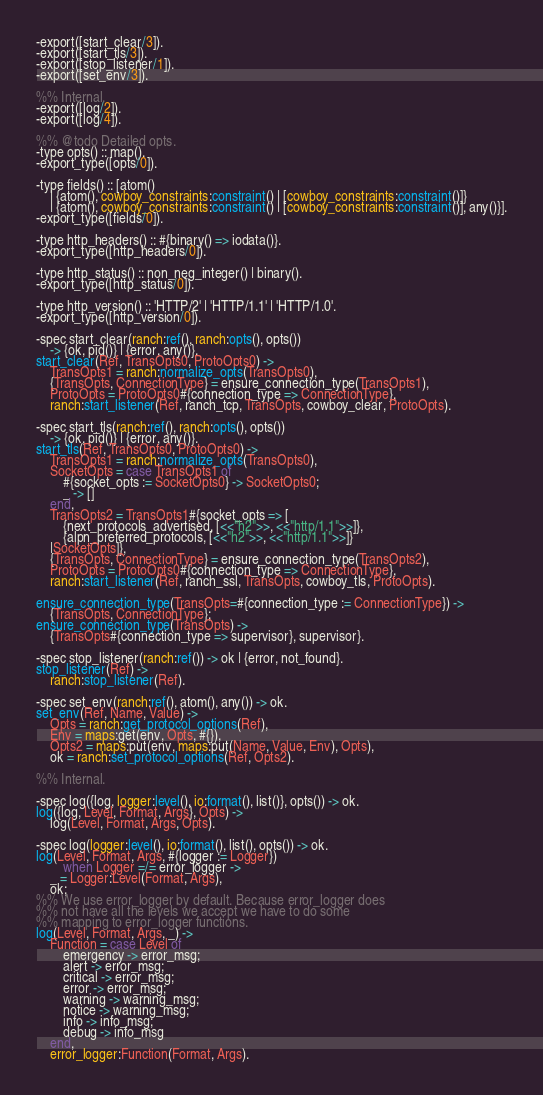<code> <loc_0><loc_0><loc_500><loc_500><_Erlang_>-export([start_clear/3]).
-export([start_tls/3]).
-export([stop_listener/1]).
-export([set_env/3]).

%% Internal.
-export([log/2]).
-export([log/4]).

%% @todo Detailed opts.
-type opts() :: map().
-export_type([opts/0]).

-type fields() :: [atom()
	| {atom(), cowboy_constraints:constraint() | [cowboy_constraints:constraint()]}
	| {atom(), cowboy_constraints:constraint() | [cowboy_constraints:constraint()], any()}].
-export_type([fields/0]).

-type http_headers() :: #{binary() => iodata()}.
-export_type([http_headers/0]).

-type http_status() :: non_neg_integer() | binary().
-export_type([http_status/0]).

-type http_version() :: 'HTTP/2' | 'HTTP/1.1' | 'HTTP/1.0'.
-export_type([http_version/0]).

-spec start_clear(ranch:ref(), ranch:opts(), opts())
	-> {ok, pid()} | {error, any()}.
start_clear(Ref, TransOpts0, ProtoOpts0) ->
	TransOpts1 = ranch:normalize_opts(TransOpts0),
	{TransOpts, ConnectionType} = ensure_connection_type(TransOpts1),
	ProtoOpts = ProtoOpts0#{connection_type => ConnectionType},
	ranch:start_listener(Ref, ranch_tcp, TransOpts, cowboy_clear, ProtoOpts).

-spec start_tls(ranch:ref(), ranch:opts(), opts())
	-> {ok, pid()} | {error, any()}.
start_tls(Ref, TransOpts0, ProtoOpts0) ->
	TransOpts1 = ranch:normalize_opts(TransOpts0),
	SocketOpts = case TransOpts1 of
		#{socket_opts := SocketOpts0} -> SocketOpts0;
		_ -> []
	end,
	TransOpts2 = TransOpts1#{socket_opts => [
		{next_protocols_advertised, [<<"h2">>, <<"http/1.1">>]},
		{alpn_preferred_protocols, [<<"h2">>, <<"http/1.1">>]}
	|SocketOpts]},
	{TransOpts, ConnectionType} = ensure_connection_type(TransOpts2),
	ProtoOpts = ProtoOpts0#{connection_type => ConnectionType},
	ranch:start_listener(Ref, ranch_ssl, TransOpts, cowboy_tls, ProtoOpts).

ensure_connection_type(TransOpts=#{connection_type := ConnectionType}) ->
	{TransOpts, ConnectionType};
ensure_connection_type(TransOpts) ->
	{TransOpts#{connection_type => supervisor}, supervisor}.

-spec stop_listener(ranch:ref()) -> ok | {error, not_found}.
stop_listener(Ref) ->
	ranch:stop_listener(Ref).

-spec set_env(ranch:ref(), atom(), any()) -> ok.
set_env(Ref, Name, Value) ->
	Opts = ranch:get_protocol_options(Ref),
	Env = maps:get(env, Opts, #{}),
	Opts2 = maps:put(env, maps:put(Name, Value, Env), Opts),
	ok = ranch:set_protocol_options(Ref, Opts2).

%% Internal.

-spec log({log, logger:level(), io:format(), list()}, opts()) -> ok.
log({log, Level, Format, Args}, Opts) ->
	log(Level, Format, Args, Opts).

-spec log(logger:level(), io:format(), list(), opts()) -> ok.
log(Level, Format, Args, #{logger := Logger})
		when Logger =/= error_logger ->
	_ = Logger:Level(Format, Args),
	ok;
%% We use error_logger by default. Because error_logger does
%% not have all the levels we accept we have to do some
%% mapping to error_logger functions.
log(Level, Format, Args, _) ->
	Function = case Level of
		emergency -> error_msg;
		alert -> error_msg;
		critical -> error_msg;
		error -> error_msg;
		warning -> warning_msg;
		notice -> warning_msg;
		info -> info_msg;
		debug -> info_msg
	end,
	error_logger:Function(Format, Args).
</code> 